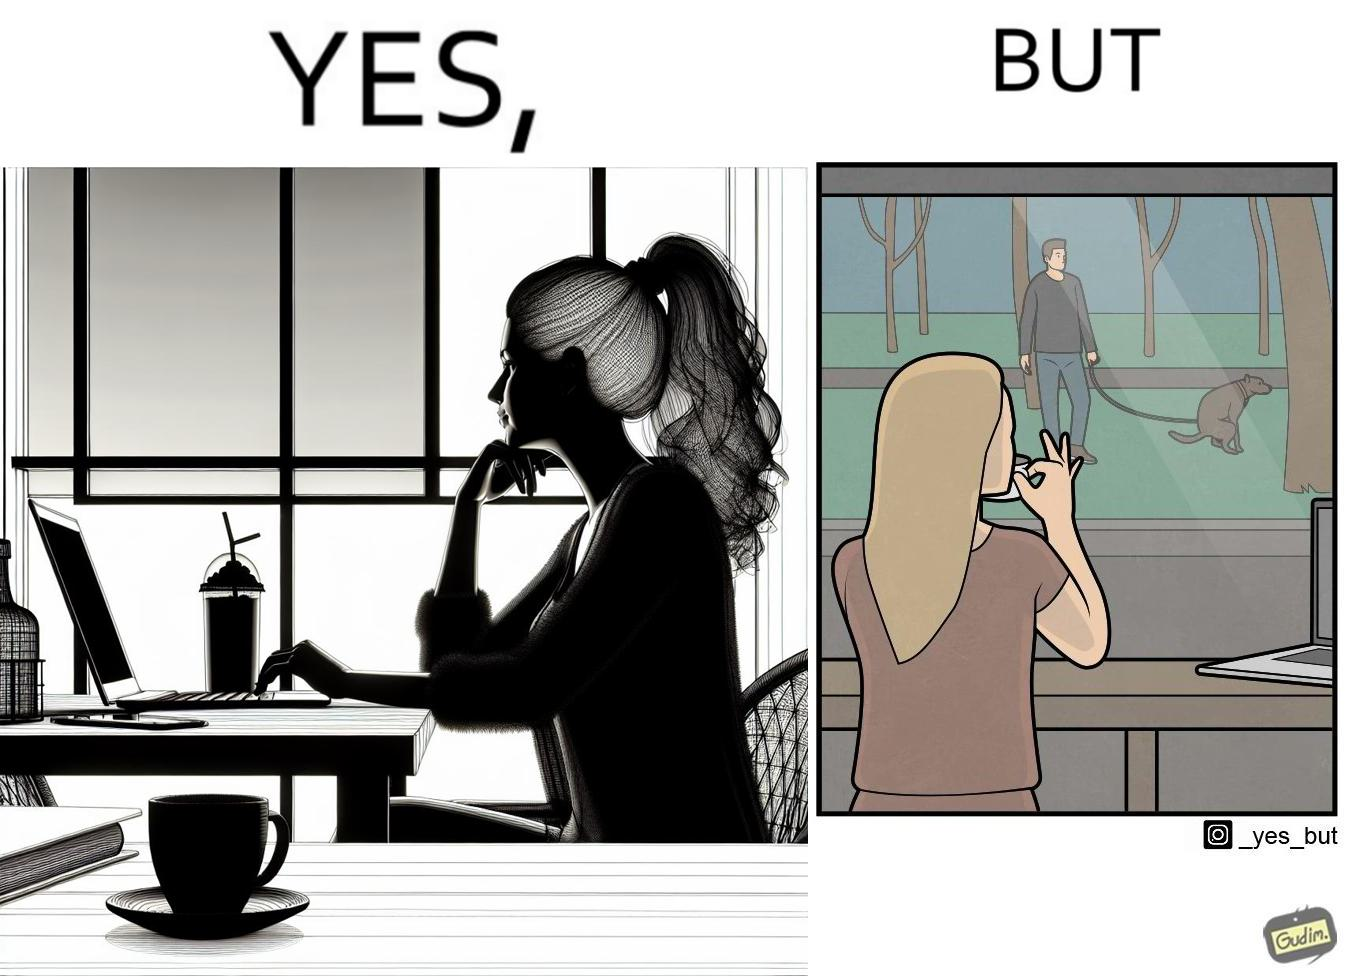Is this a satirical image? Yes, this image is satirical. 